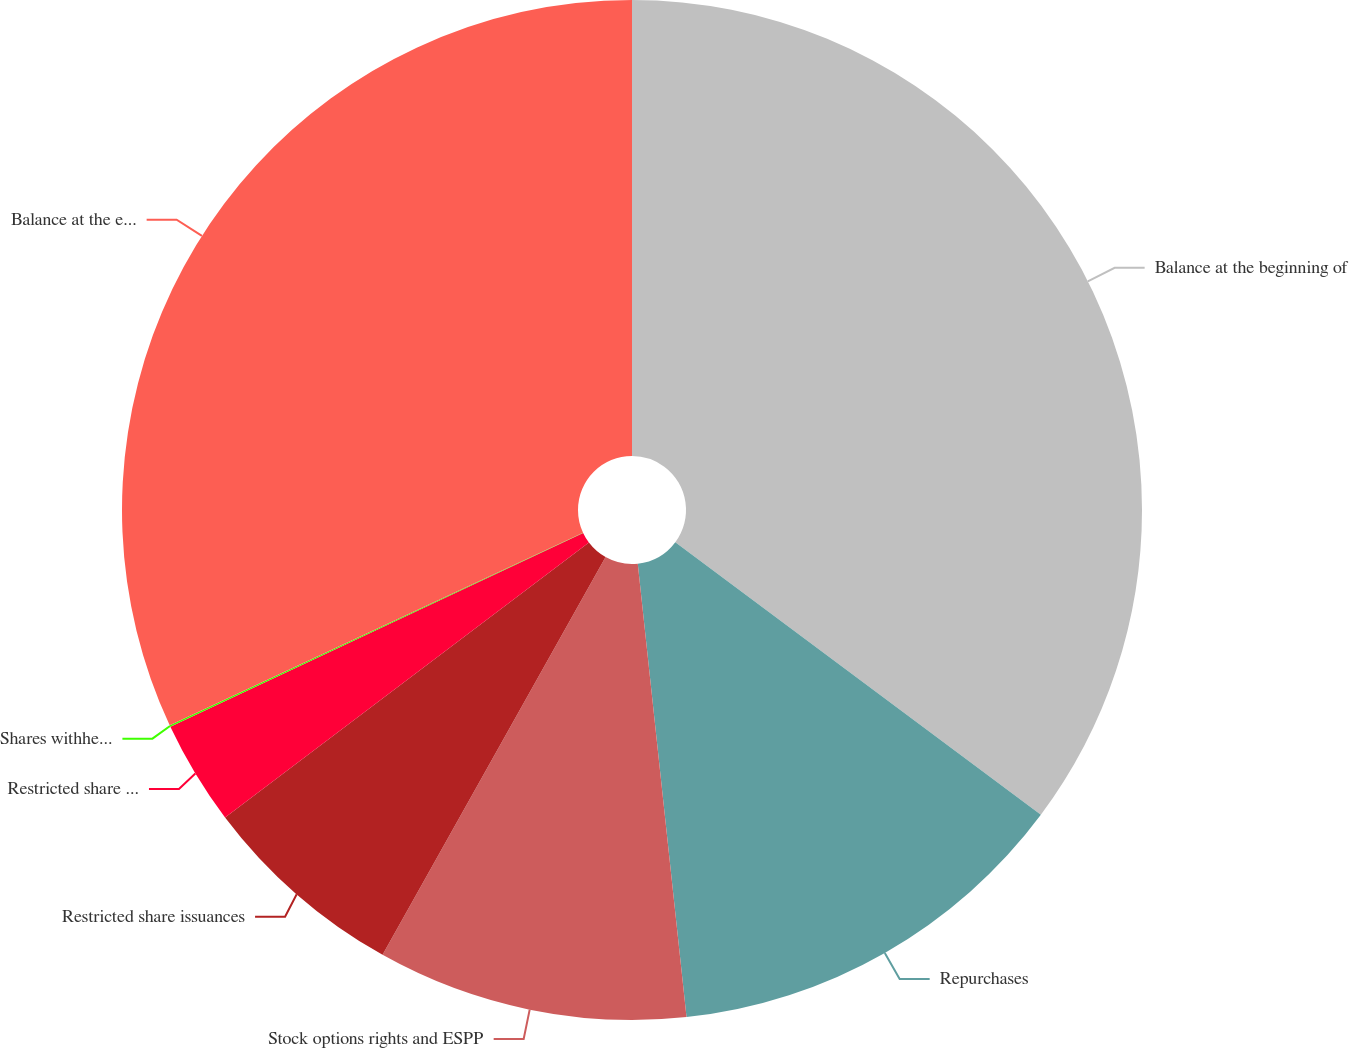Convert chart to OTSL. <chart><loc_0><loc_0><loc_500><loc_500><pie_chart><fcel>Balance at the beginning of<fcel>Repurchases<fcel>Stock options rights and ESPP<fcel>Restricted share issuances<fcel>Restricted share forfeitures<fcel>Shares withheld for tax<fcel>Balance at the end of the<nl><fcel>35.2%<fcel>13.1%<fcel>9.84%<fcel>6.57%<fcel>3.31%<fcel>0.05%<fcel>31.94%<nl></chart> 